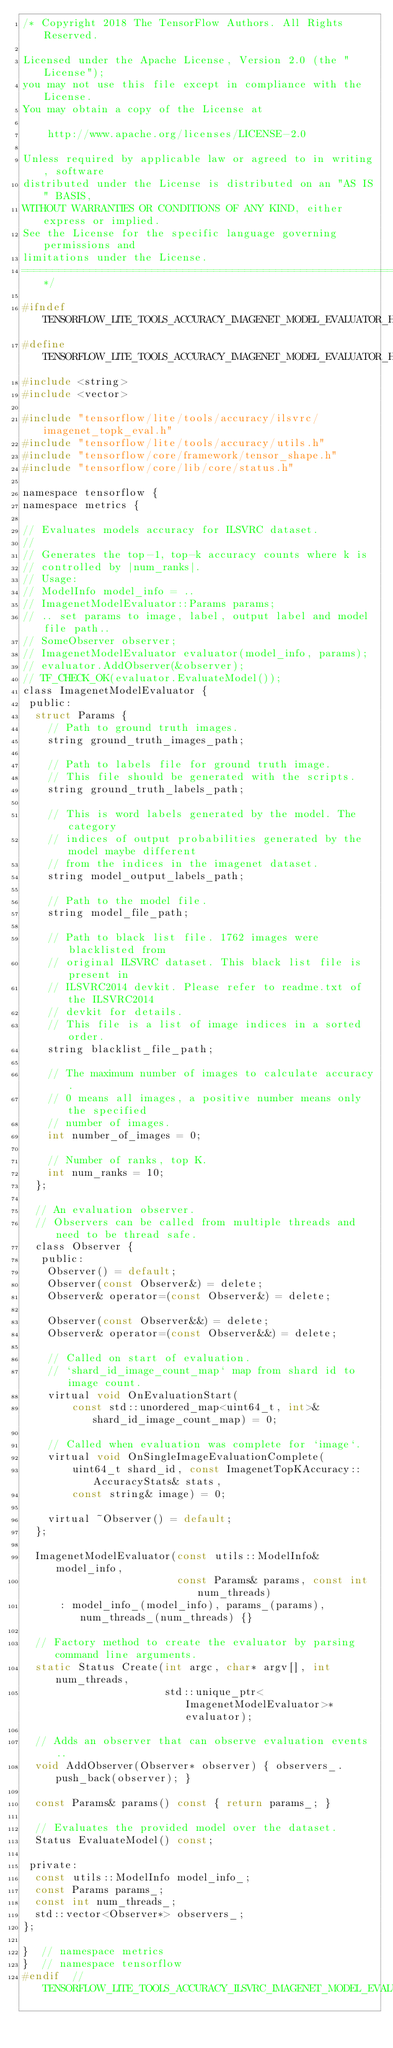Convert code to text. <code><loc_0><loc_0><loc_500><loc_500><_C_>/* Copyright 2018 The TensorFlow Authors. All Rights Reserved.

Licensed under the Apache License, Version 2.0 (the "License");
you may not use this file except in compliance with the License.
You may obtain a copy of the License at

    http://www.apache.org/licenses/LICENSE-2.0

Unless required by applicable law or agreed to in writing, software
distributed under the License is distributed on an "AS IS" BASIS,
WITHOUT WARRANTIES OR CONDITIONS OF ANY KIND, either express or implied.
See the License for the specific language governing permissions and
limitations under the License.
==============================================================================*/

#ifndef TENSORFLOW_LITE_TOOLS_ACCURACY_IMAGENET_MODEL_EVALUATOR_H_
#define TENSORFLOW_LITE_TOOLS_ACCURACY_IMAGENET_MODEL_EVALUATOR_H_
#include <string>
#include <vector>

#include "tensorflow/lite/tools/accuracy/ilsvrc/imagenet_topk_eval.h"
#include "tensorflow/lite/tools/accuracy/utils.h"
#include "tensorflow/core/framework/tensor_shape.h"
#include "tensorflow/core/lib/core/status.h"

namespace tensorflow {
namespace metrics {

// Evaluates models accuracy for ILSVRC dataset.
//
// Generates the top-1, top-k accuracy counts where k is
// controlled by |num_ranks|.
// Usage:
// ModelInfo model_info = ..
// ImagenetModelEvaluator::Params params;
// .. set params to image, label, output label and model file path..
// SomeObserver observer;
// ImagenetModelEvaluator evaluator(model_info, params);
// evaluator.AddObserver(&observer);
// TF_CHECK_OK(evaluator.EvaluateModel());
class ImagenetModelEvaluator {
 public:
  struct Params {
    // Path to ground truth images.
    string ground_truth_images_path;

    // Path to labels file for ground truth image.
    // This file should be generated with the scripts.
    string ground_truth_labels_path;

    // This is word labels generated by the model. The category
    // indices of output probabilities generated by the model maybe different
    // from the indices in the imagenet dataset.
    string model_output_labels_path;

    // Path to the model file.
    string model_file_path;

    // Path to black list file. 1762 images were blacklisted from
    // original ILSVRC dataset. This black list file is present in
    // ILSVRC2014 devkit. Please refer to readme.txt of the ILSVRC2014
    // devkit for details.
    // This file is a list of image indices in a sorted order.
    string blacklist_file_path;

    // The maximum number of images to calculate accuracy.
    // 0 means all images, a positive number means only the specified
    // number of images.
    int number_of_images = 0;

    // Number of ranks, top K.
    int num_ranks = 10;
  };

  // An evaluation observer.
  // Observers can be called from multiple threads and need to be thread safe.
  class Observer {
   public:
    Observer() = default;
    Observer(const Observer&) = delete;
    Observer& operator=(const Observer&) = delete;

    Observer(const Observer&&) = delete;
    Observer& operator=(const Observer&&) = delete;

    // Called on start of evaluation.
    // `shard_id_image_count_map` map from shard id to image count.
    virtual void OnEvaluationStart(
        const std::unordered_map<uint64_t, int>& shard_id_image_count_map) = 0;

    // Called when evaluation was complete for `image`.
    virtual void OnSingleImageEvaluationComplete(
        uint64_t shard_id, const ImagenetTopKAccuracy::AccuracyStats& stats,
        const string& image) = 0;

    virtual ~Observer() = default;
  };

  ImagenetModelEvaluator(const utils::ModelInfo& model_info,
                         const Params& params, const int num_threads)
      : model_info_(model_info), params_(params), num_threads_(num_threads) {}

  // Factory method to create the evaluator by parsing command line arguments.
  static Status Create(int argc, char* argv[], int num_threads,
                       std::unique_ptr<ImagenetModelEvaluator>* evaluator);

  // Adds an observer that can observe evaluation events..
  void AddObserver(Observer* observer) { observers_.push_back(observer); }

  const Params& params() const { return params_; }

  // Evaluates the provided model over the dataset.
  Status EvaluateModel() const;

 private:
  const utils::ModelInfo model_info_;
  const Params params_;
  const int num_threads_;
  std::vector<Observer*> observers_;
};

}  // namespace metrics
}  // namespace tensorflow
#endif  // TENSORFLOW_LITE_TOOLS_ACCURACY_ILSVRC_IMAGENET_MODEL_EVALUATOR_H_
</code> 